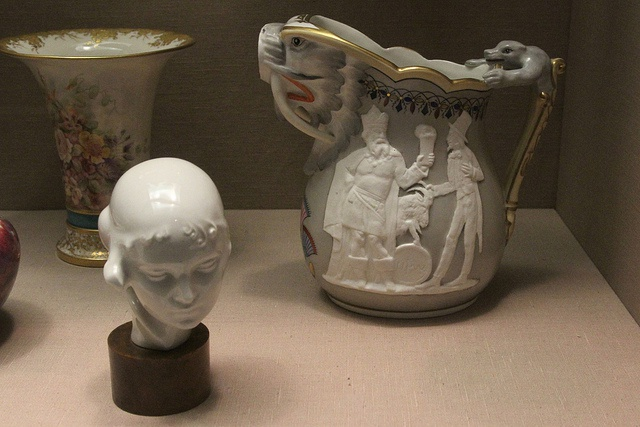Describe the objects in this image and their specific colors. I can see vase in black, gray, and darkgray tones and vase in black, gray, and darkgray tones in this image. 